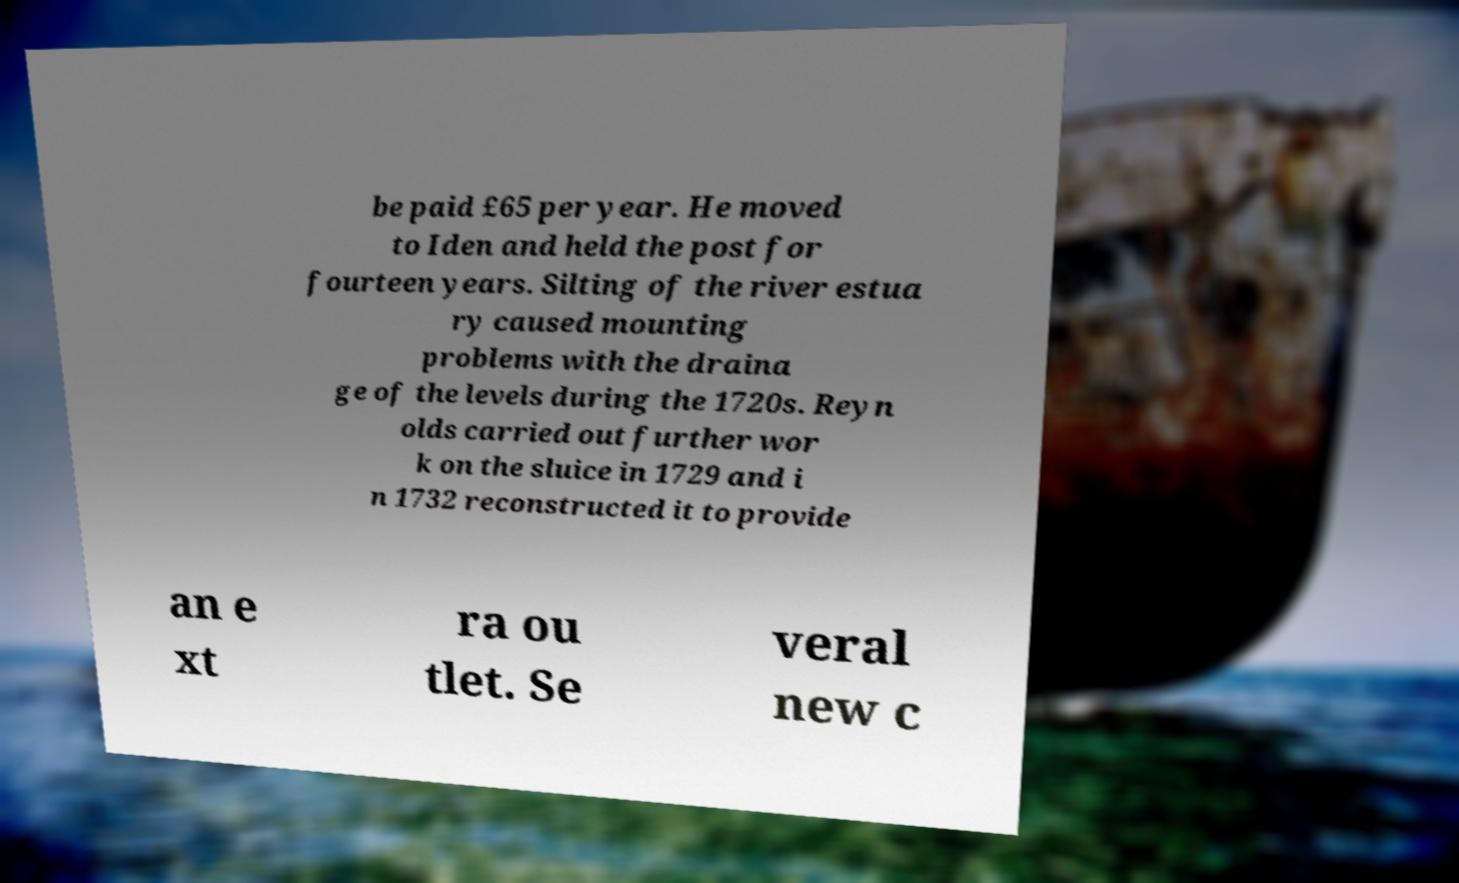Could you assist in decoding the text presented in this image and type it out clearly? be paid £65 per year. He moved to Iden and held the post for fourteen years. Silting of the river estua ry caused mounting problems with the draina ge of the levels during the 1720s. Reyn olds carried out further wor k on the sluice in 1729 and i n 1732 reconstructed it to provide an e xt ra ou tlet. Se veral new c 